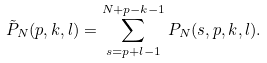Convert formula to latex. <formula><loc_0><loc_0><loc_500><loc_500>\tilde { P } _ { N } ( p , k , l ) = \sum _ { s = p + l - 1 } ^ { N + p - k - 1 } P _ { N } ( s , p , k , l ) .</formula> 